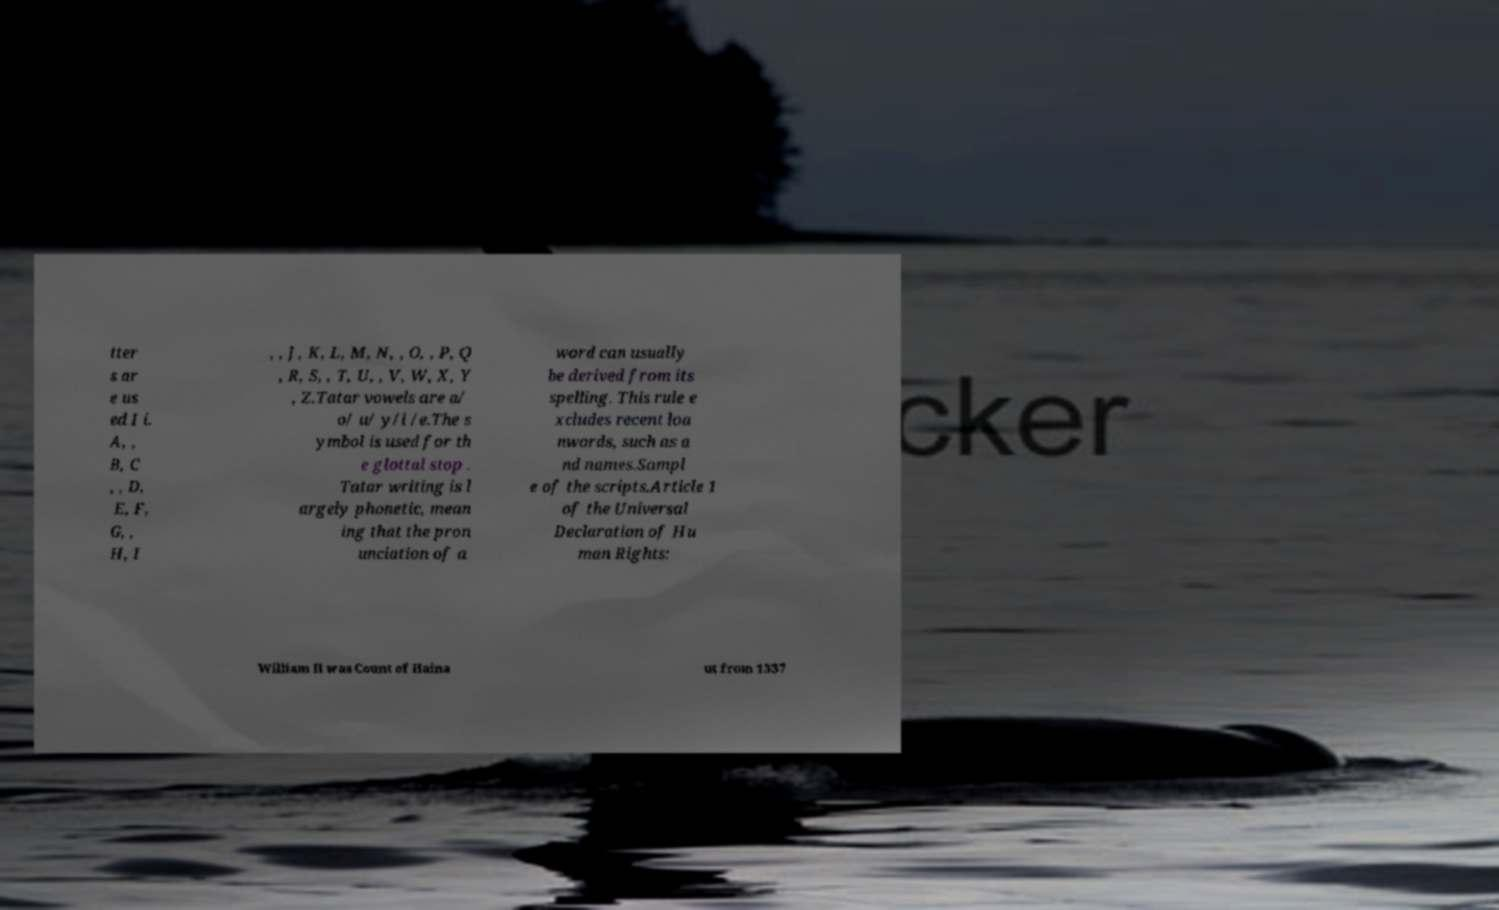Could you assist in decoding the text presented in this image and type it out clearly? tter s ar e us ed I i. A, , B, C , , D, E, F, G, , H, I , , J, K, L, M, N, , O, , P, Q , R, S, , T, U, , V, W, X, Y , Z.Tatar vowels are a/ o/ u/ y/i /e.The s ymbol is used for th e glottal stop . Tatar writing is l argely phonetic, mean ing that the pron unciation of a word can usually be derived from its spelling. This rule e xcludes recent loa nwords, such as a nd names.Sampl e of the scripts.Article 1 of the Universal Declaration of Hu man Rights: William II was Count of Haina ut from 1337 